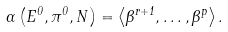Convert formula to latex. <formula><loc_0><loc_0><loc_500><loc_500>\Gamma \left ( E ^ { 0 } , \pi ^ { 0 } , N \right ) = \left \langle \Theta ^ { r + 1 } , \dots , \Theta ^ { p } \right \rangle .</formula> 